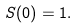Convert formula to latex. <formula><loc_0><loc_0><loc_500><loc_500>S ( { 0 } ) = 1 .</formula> 